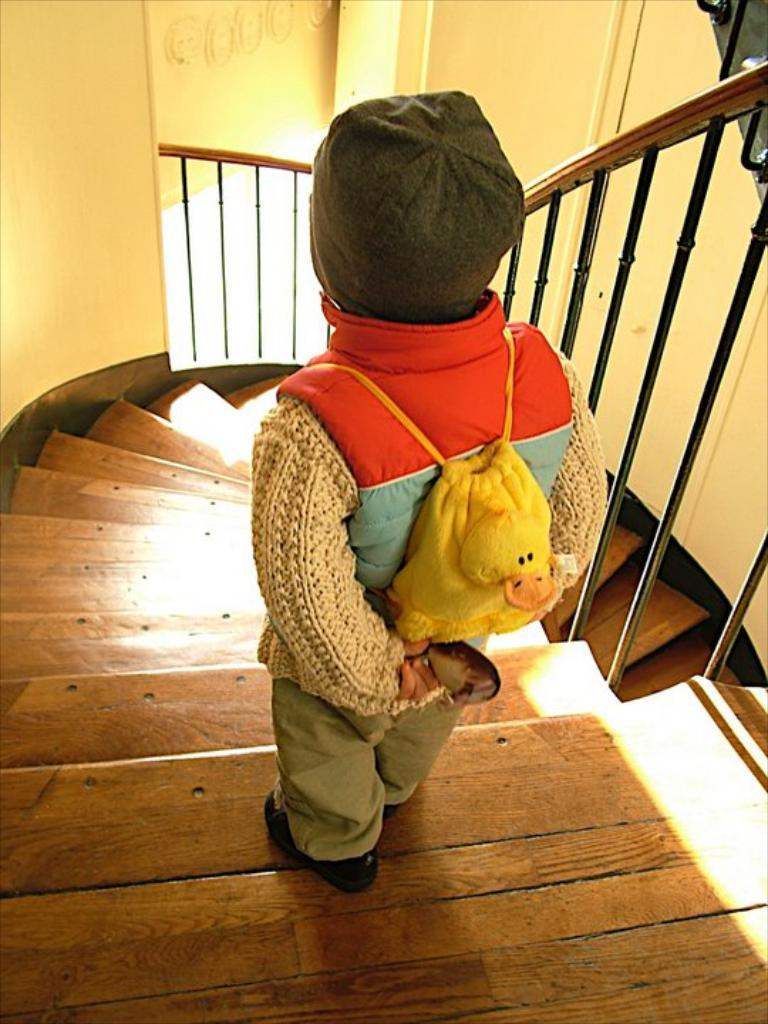Who is the main subject in the image? There is a girl in the image. What is the girl wearing? The girl is wearing a sweatshirt. Where is the girl standing? The girl is standing on wooden steps. What can be seen on either side of the steps? There is a fence on either side of the steps. What type of volleyball is the girl playing in the image? There is no volleyball present in the image; the girl is standing on wooden steps with fences on either side. What effect does the girl's presence have on the airplane in the image? There is no airplane present in the image, so it is not possible to determine any effect the girl might have on it. 